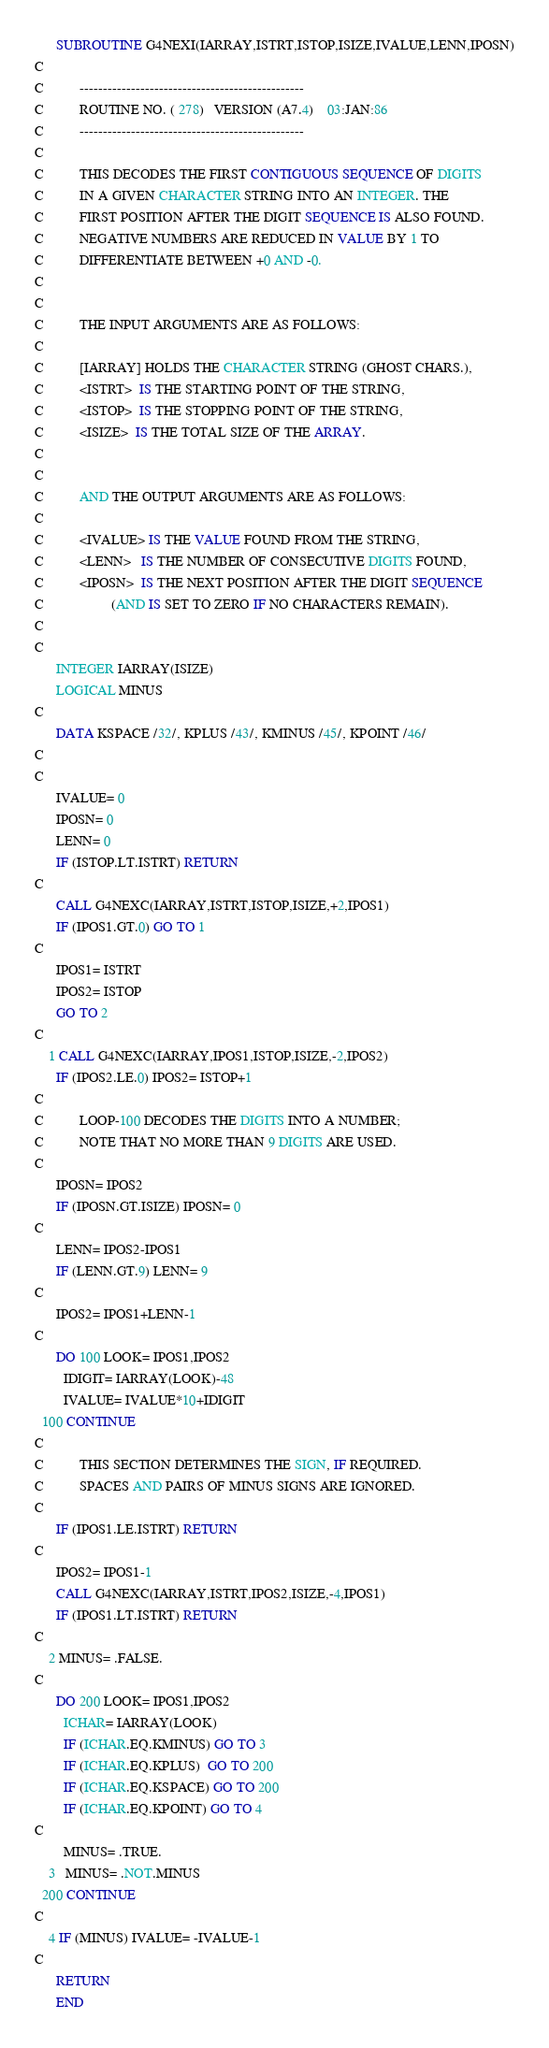<code> <loc_0><loc_0><loc_500><loc_500><_FORTRAN_>      SUBROUTINE G4NEXI(IARRAY,ISTRT,ISTOP,ISIZE,IVALUE,LENN,IPOSN)
C
C          ------------------------------------------------
C          ROUTINE NO. ( 278)   VERSION (A7.4)    03:JAN:86
C          ------------------------------------------------
C
C          THIS DECODES THE FIRST CONTIGUOUS SEQUENCE OF DIGITS
C          IN A GIVEN CHARACTER STRING INTO AN INTEGER. THE
C          FIRST POSITION AFTER THE DIGIT SEQUENCE IS ALSO FOUND.
C          NEGATIVE NUMBERS ARE REDUCED IN VALUE BY 1 TO
C          DIFFERENTIATE BETWEEN +0 AND -0.
C
C
C          THE INPUT ARGUMENTS ARE AS FOLLOWS:
C
C          [IARRAY] HOLDS THE CHARACTER STRING (GHOST CHARS.),
C          <ISTRT>  IS THE STARTING POINT OF THE STRING,
C          <ISTOP>  IS THE STOPPING POINT OF THE STRING,
C          <ISIZE>  IS THE TOTAL SIZE OF THE ARRAY.
C
C
C          AND THE OUTPUT ARGUMENTS ARE AS FOLLOWS:
C
C          <IVALUE> IS THE VALUE FOUND FROM THE STRING,
C          <LENN>   IS THE NUMBER OF CONSECUTIVE DIGITS FOUND,
C          <IPOSN>  IS THE NEXT POSITION AFTER THE DIGIT SEQUENCE
C                   (AND IS SET TO ZERO IF NO CHARACTERS REMAIN).
C
C
      INTEGER IARRAY(ISIZE)
      LOGICAL MINUS
C
      DATA KSPACE /32/, KPLUS /43/, KMINUS /45/, KPOINT /46/
C
C
      IVALUE= 0
      IPOSN= 0
      LENN= 0
      IF (ISTOP.LT.ISTRT) RETURN
C
      CALL G4NEXC(IARRAY,ISTRT,ISTOP,ISIZE,+2,IPOS1)
      IF (IPOS1.GT.0) GO TO 1
C
      IPOS1= ISTRT
      IPOS2= ISTOP
      GO TO 2
C
    1 CALL G4NEXC(IARRAY,IPOS1,ISTOP,ISIZE,-2,IPOS2)
      IF (IPOS2.LE.0) IPOS2= ISTOP+1
C
C          LOOP-100 DECODES THE DIGITS INTO A NUMBER;
C          NOTE THAT NO MORE THAN 9 DIGITS ARE USED.
C
      IPOSN= IPOS2
      IF (IPOSN.GT.ISIZE) IPOSN= 0
C
      LENN= IPOS2-IPOS1
      IF (LENN.GT.9) LENN= 9
C
      IPOS2= IPOS1+LENN-1
C
      DO 100 LOOK= IPOS1,IPOS2
        IDIGIT= IARRAY(LOOK)-48
        IVALUE= IVALUE*10+IDIGIT
  100 CONTINUE
C
C          THIS SECTION DETERMINES THE SIGN, IF REQUIRED.
C          SPACES AND PAIRS OF MINUS SIGNS ARE IGNORED.
C
      IF (IPOS1.LE.ISTRT) RETURN
C
      IPOS2= IPOS1-1
      CALL G4NEXC(IARRAY,ISTRT,IPOS2,ISIZE,-4,IPOS1)
      IF (IPOS1.LT.ISTRT) RETURN
C
    2 MINUS= .FALSE.
C
      DO 200 LOOK= IPOS1,IPOS2
        ICHAR= IARRAY(LOOK)
        IF (ICHAR.EQ.KMINUS) GO TO 3
        IF (ICHAR.EQ.KPLUS)  GO TO 200
        IF (ICHAR.EQ.KSPACE) GO TO 200
        IF (ICHAR.EQ.KPOINT) GO TO 4
C
        MINUS= .TRUE.
    3   MINUS= .NOT.MINUS
  200 CONTINUE
C
    4 IF (MINUS) IVALUE= -IVALUE-1
C
      RETURN
      END
</code> 